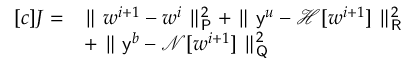Convert formula to latex. <formula><loc_0><loc_0><loc_500><loc_500>\begin{array} { r l } { [ c ] J = } & { \| w ^ { i + 1 } - w ^ { i } \| _ { P } ^ { 2 } + \| y ^ { u } - \mathcal { H } [ w ^ { i + 1 } ] \| _ { R } ^ { 2 } } \\ & { + \| y ^ { b } - \mathcal { N } [ w ^ { i + 1 } ] \| _ { Q } ^ { 2 } } \end{array}</formula> 